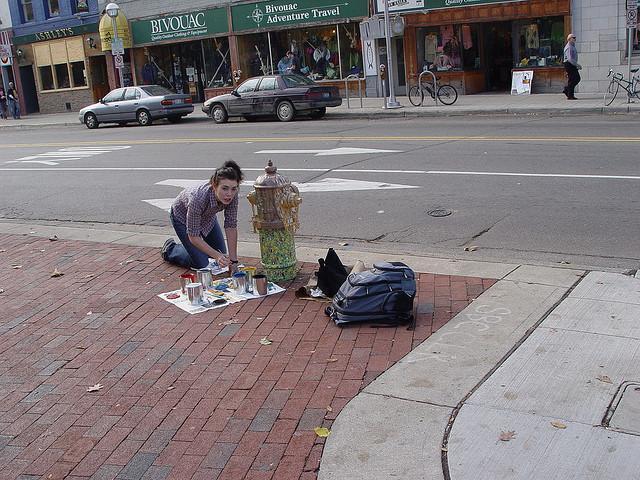What is the woman doing to the fire hydrant?
Choose the correct response, then elucidate: 'Answer: answer
Rationale: rationale.'
Options: Cleaning it, building it, painting it, dismantling it. Answer: painting it.
Rationale: The woman is painting. 